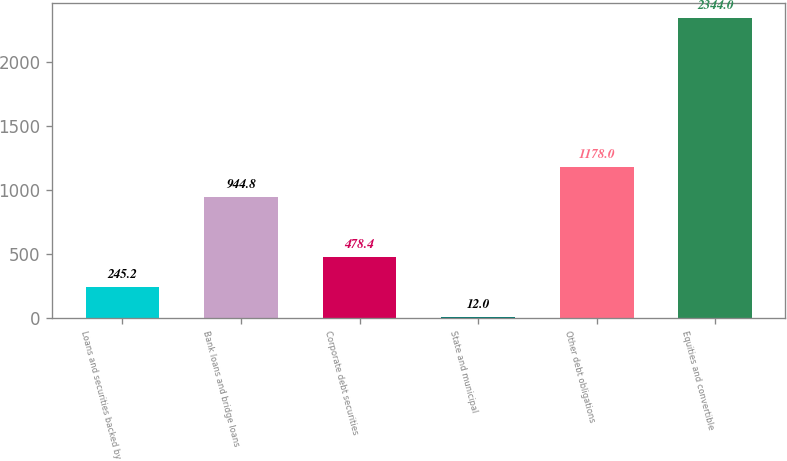<chart> <loc_0><loc_0><loc_500><loc_500><bar_chart><fcel>Loans and securities backed by<fcel>Bank loans and bridge loans<fcel>Corporate debt securities<fcel>State and municipal<fcel>Other debt obligations<fcel>Equities and convertible<nl><fcel>245.2<fcel>944.8<fcel>478.4<fcel>12<fcel>1178<fcel>2344<nl></chart> 